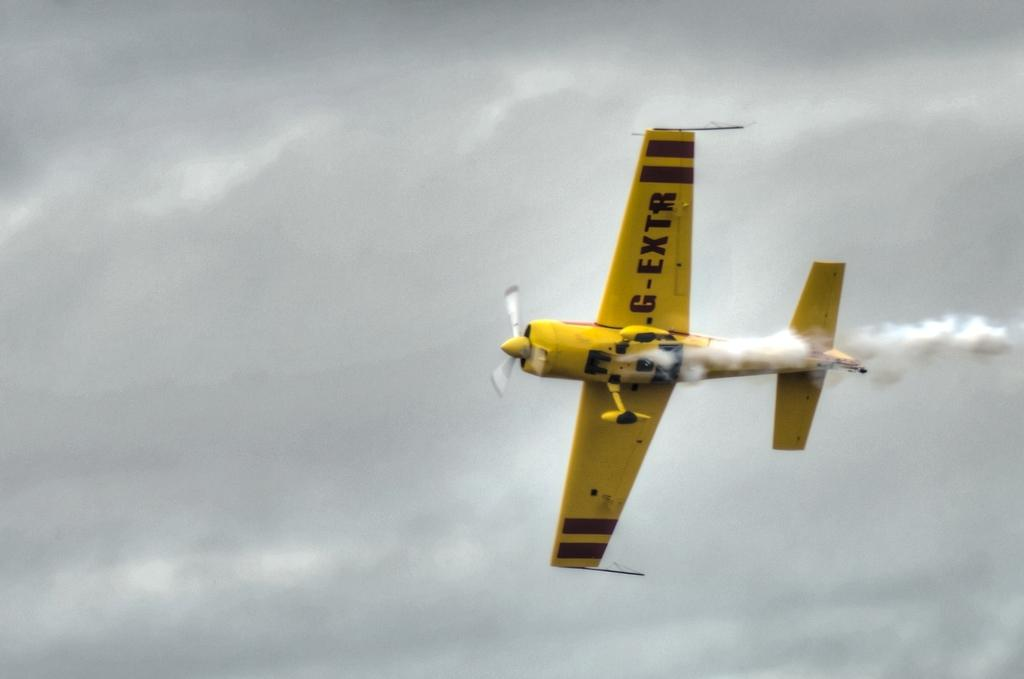<image>
Share a concise interpretation of the image provided. A yellow plane flying in the sky says G-Extr on the underside of the wings. 